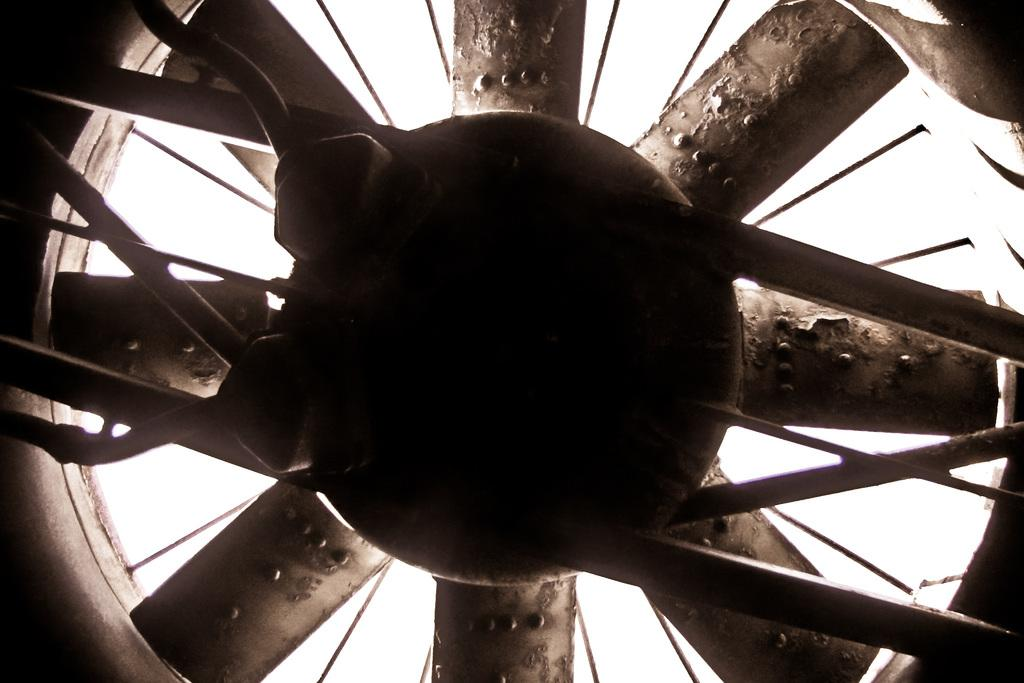What object can be seen in the image? There is a fan in the image. What color is the background of the image? The background of the image is white. How many chairs are visible in the image? There are no chairs present in the image. Is there a visitor in the image? There is no visitor present in the image. 